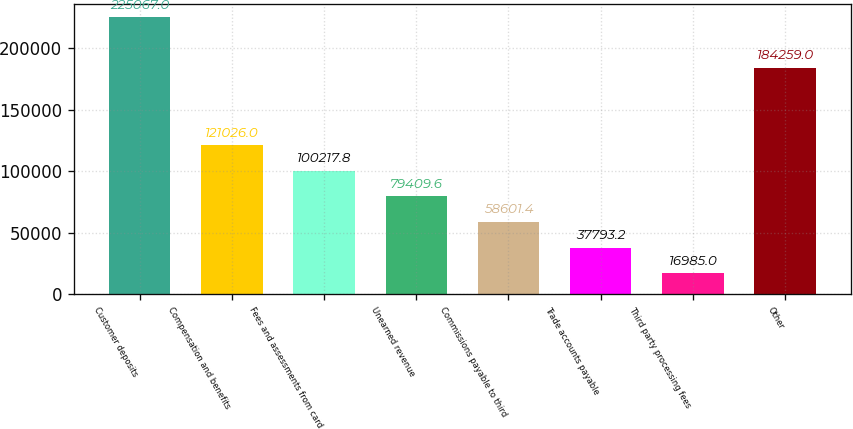Convert chart to OTSL. <chart><loc_0><loc_0><loc_500><loc_500><bar_chart><fcel>Customer deposits<fcel>Compensation and benefits<fcel>Fees and assessments from card<fcel>Unearned revenue<fcel>Commissions payable to third<fcel>Trade accounts payable<fcel>Third party processing fees<fcel>Other<nl><fcel>225067<fcel>121026<fcel>100218<fcel>79409.6<fcel>58601.4<fcel>37793.2<fcel>16985<fcel>184259<nl></chart> 